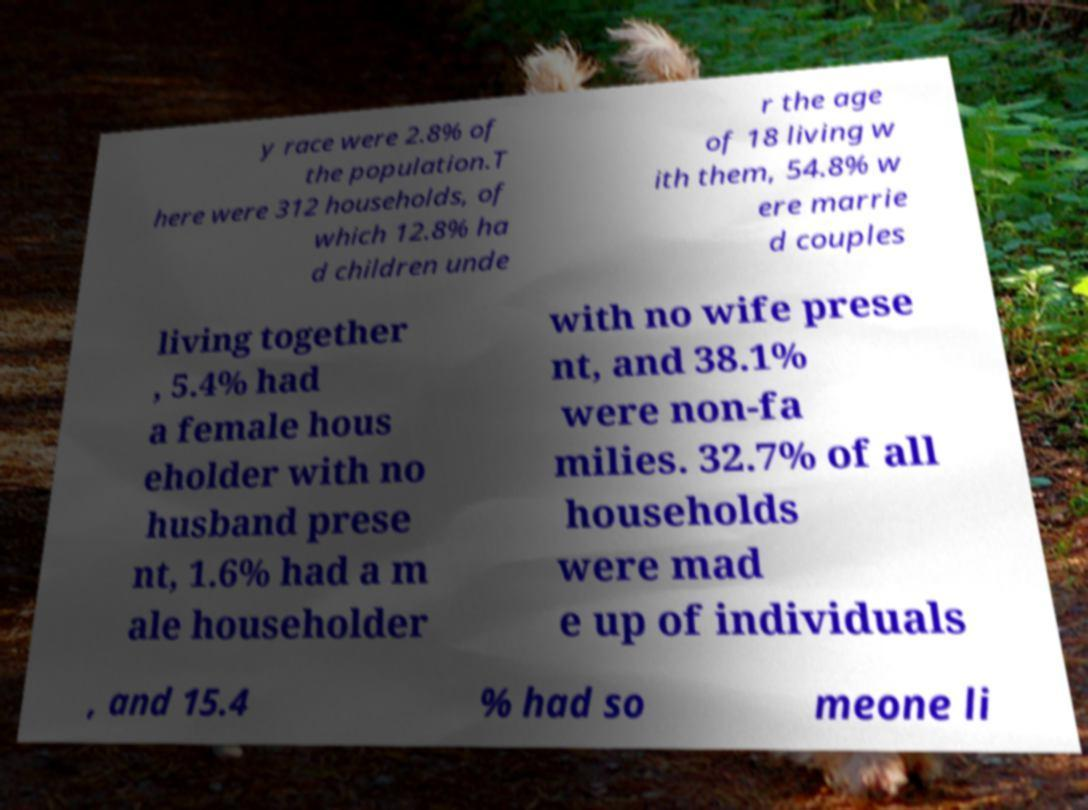I need the written content from this picture converted into text. Can you do that? y race were 2.8% of the population.T here were 312 households, of which 12.8% ha d children unde r the age of 18 living w ith them, 54.8% w ere marrie d couples living together , 5.4% had a female hous eholder with no husband prese nt, 1.6% had a m ale householder with no wife prese nt, and 38.1% were non-fa milies. 32.7% of all households were mad e up of individuals , and 15.4 % had so meone li 